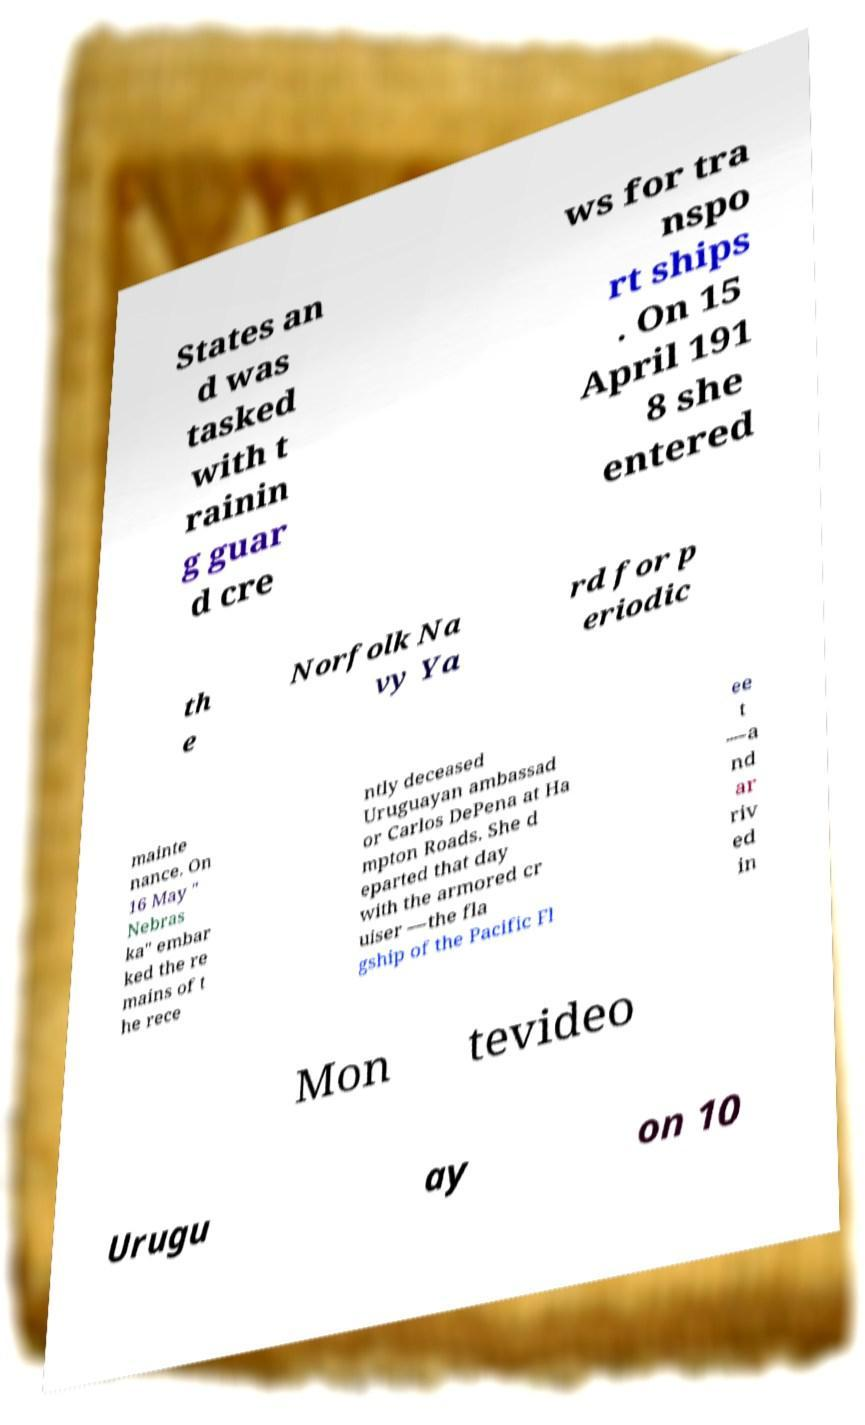Could you assist in decoding the text presented in this image and type it out clearly? States an d was tasked with t rainin g guar d cre ws for tra nspo rt ships . On 15 April 191 8 she entered th e Norfolk Na vy Ya rd for p eriodic mainte nance. On 16 May " Nebras ka" embar ked the re mains of t he rece ntly deceased Uruguayan ambassad or Carlos DePena at Ha mpton Roads. She d eparted that day with the armored cr uiser —the fla gship of the Pacific Fl ee t —a nd ar riv ed in Mon tevideo Urugu ay on 10 